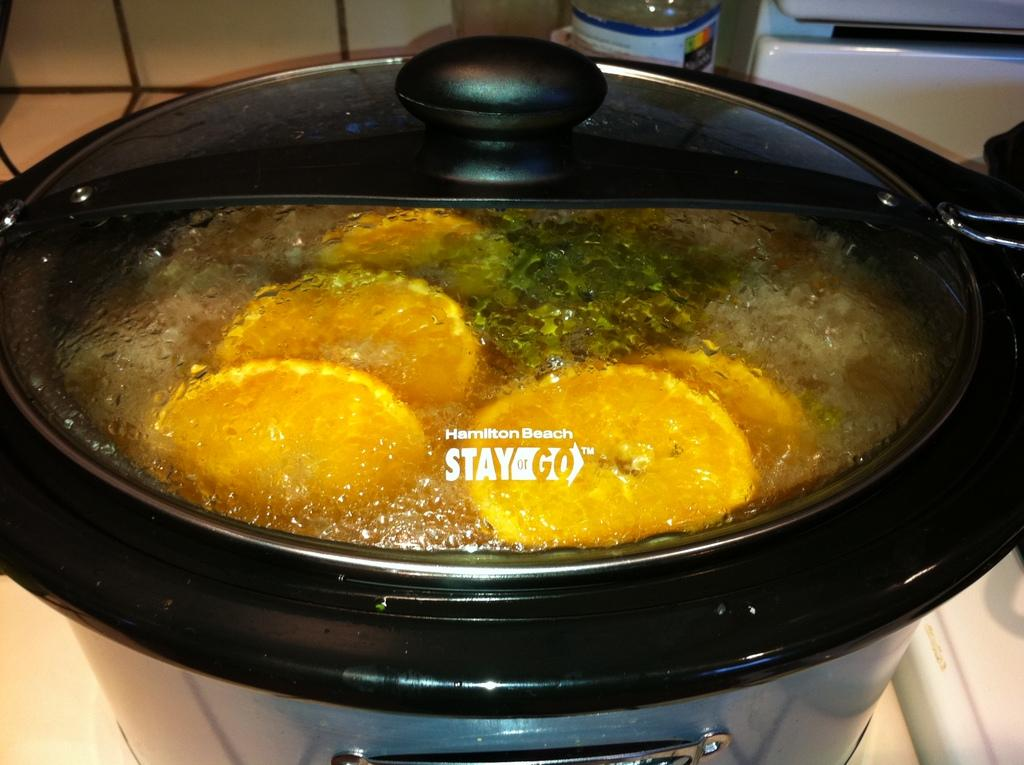Provide a one-sentence caption for the provided image. A pan sits on a hob with a lid bearing the logo Hamilton Beach Stay n Go. 